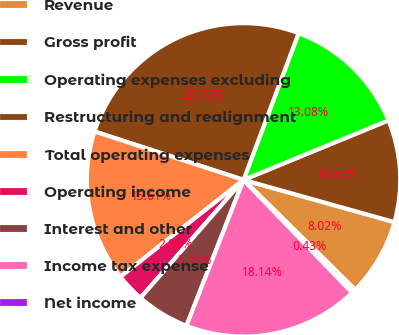Convert chart. <chart><loc_0><loc_0><loc_500><loc_500><pie_chart><fcel>Revenue<fcel>Gross profit<fcel>Operating expenses excluding<fcel>Restructuring and realignment<fcel>Total operating expenses<fcel>Operating income<fcel>Interest and other<fcel>Income tax expense<fcel>Net income<nl><fcel>8.02%<fcel>10.55%<fcel>13.08%<fcel>25.72%<fcel>15.61%<fcel>2.96%<fcel>5.49%<fcel>18.14%<fcel>0.43%<nl></chart> 